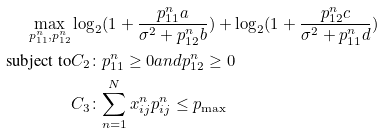Convert formula to latex. <formula><loc_0><loc_0><loc_500><loc_500>\max _ { p ^ { n } _ { 1 1 } , p ^ { n } _ { 1 2 } } & \log _ { 2 } ( 1 + \frac { p ^ { n } _ { 1 1 } a } { \sigma ^ { 2 } + p ^ { n } _ { 1 2 } b } ) + \log _ { 2 } ( 1 + \frac { p ^ { n } _ { 1 2 } c } { \sigma ^ { 2 } + p ^ { n } _ { 1 1 } d } ) \\ \text {subject to} & { { C } _ { 2 } } \colon p _ { 1 1 } ^ { n } \geq 0 a n d p _ { 1 2 } ^ { n } \geq 0 \\ & { { C } _ { 3 } } \colon \underset { n = 1 } { \overset { N } { \mathop \sum } } \, x _ { i j } ^ { n } p _ { i j } ^ { n } \leq { { p } _ { \max } } \\</formula> 